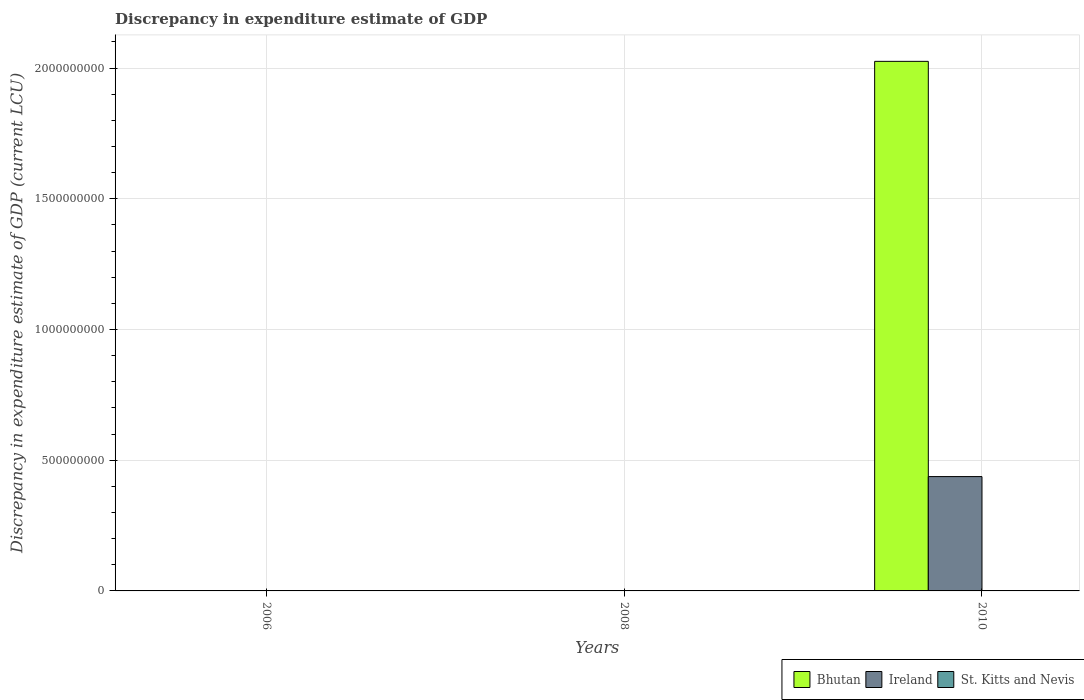How many different coloured bars are there?
Your answer should be compact. 3. Are the number of bars per tick equal to the number of legend labels?
Make the answer very short. No. Are the number of bars on each tick of the X-axis equal?
Make the answer very short. No. How many bars are there on the 3rd tick from the left?
Offer a very short reply. 3. How many bars are there on the 3rd tick from the right?
Give a very brief answer. 1. What is the label of the 3rd group of bars from the left?
Provide a short and direct response. 2010. In how many cases, is the number of bars for a given year not equal to the number of legend labels?
Your answer should be compact. 2. What is the discrepancy in expenditure estimate of GDP in St. Kitts and Nevis in 2008?
Ensure brevity in your answer.  2e-7. Across all years, what is the maximum discrepancy in expenditure estimate of GDP in St. Kitts and Nevis?
Provide a short and direct response. 3.2e-7. Across all years, what is the minimum discrepancy in expenditure estimate of GDP in Ireland?
Keep it short and to the point. 0. In which year was the discrepancy in expenditure estimate of GDP in St. Kitts and Nevis maximum?
Your answer should be very brief. 2010. What is the total discrepancy in expenditure estimate of GDP in Ireland in the graph?
Make the answer very short. 4.37e+08. What is the difference between the discrepancy in expenditure estimate of GDP in Bhutan in 2006 and that in 2008?
Your response must be concise. 4.000000000000001e-6. What is the difference between the discrepancy in expenditure estimate of GDP in St. Kitts and Nevis in 2008 and the discrepancy in expenditure estimate of GDP in Bhutan in 2010?
Give a very brief answer. -2.03e+09. What is the average discrepancy in expenditure estimate of GDP in Ireland per year?
Your response must be concise. 1.46e+08. In the year 2010, what is the difference between the discrepancy in expenditure estimate of GDP in Bhutan and discrepancy in expenditure estimate of GDP in St. Kitts and Nevis?
Ensure brevity in your answer.  2.03e+09. In how many years, is the discrepancy in expenditure estimate of GDP in Ireland greater than 1700000000 LCU?
Your response must be concise. 0. What is the ratio of the discrepancy in expenditure estimate of GDP in St. Kitts and Nevis in 2008 to that in 2010?
Ensure brevity in your answer.  0.62. What is the difference between the highest and the second highest discrepancy in expenditure estimate of GDP in Bhutan?
Make the answer very short. 2.03e+09. What is the difference between the highest and the lowest discrepancy in expenditure estimate of GDP in St. Kitts and Nevis?
Give a very brief answer. 3.2e-7. How many bars are there?
Offer a terse response. 6. Are all the bars in the graph horizontal?
Your answer should be compact. No. How many years are there in the graph?
Ensure brevity in your answer.  3. Are the values on the major ticks of Y-axis written in scientific E-notation?
Give a very brief answer. No. Does the graph contain any zero values?
Offer a very short reply. Yes. Where does the legend appear in the graph?
Give a very brief answer. Bottom right. How are the legend labels stacked?
Keep it short and to the point. Horizontal. What is the title of the graph?
Your response must be concise. Discrepancy in expenditure estimate of GDP. Does "Macao" appear as one of the legend labels in the graph?
Offer a terse response. No. What is the label or title of the X-axis?
Ensure brevity in your answer.  Years. What is the label or title of the Y-axis?
Ensure brevity in your answer.  Discrepancy in expenditure estimate of GDP (current LCU). What is the Discrepancy in expenditure estimate of GDP (current LCU) of Bhutan in 2006?
Your answer should be very brief. 6e-6. What is the Discrepancy in expenditure estimate of GDP (current LCU) of Ireland in 2006?
Ensure brevity in your answer.  0. What is the Discrepancy in expenditure estimate of GDP (current LCU) of St. Kitts and Nevis in 2006?
Give a very brief answer. 0. What is the Discrepancy in expenditure estimate of GDP (current LCU) in Bhutan in 2008?
Give a very brief answer. 2e-6. What is the Discrepancy in expenditure estimate of GDP (current LCU) in St. Kitts and Nevis in 2008?
Make the answer very short. 2e-7. What is the Discrepancy in expenditure estimate of GDP (current LCU) of Bhutan in 2010?
Your response must be concise. 2.03e+09. What is the Discrepancy in expenditure estimate of GDP (current LCU) in Ireland in 2010?
Provide a succinct answer. 4.37e+08. What is the Discrepancy in expenditure estimate of GDP (current LCU) of St. Kitts and Nevis in 2010?
Your answer should be compact. 3.2e-7. Across all years, what is the maximum Discrepancy in expenditure estimate of GDP (current LCU) of Bhutan?
Your answer should be compact. 2.03e+09. Across all years, what is the maximum Discrepancy in expenditure estimate of GDP (current LCU) of Ireland?
Your answer should be compact. 4.37e+08. Across all years, what is the maximum Discrepancy in expenditure estimate of GDP (current LCU) in St. Kitts and Nevis?
Your answer should be very brief. 3.2e-7. Across all years, what is the minimum Discrepancy in expenditure estimate of GDP (current LCU) in Bhutan?
Make the answer very short. 2e-6. Across all years, what is the minimum Discrepancy in expenditure estimate of GDP (current LCU) in Ireland?
Ensure brevity in your answer.  0. Across all years, what is the minimum Discrepancy in expenditure estimate of GDP (current LCU) in St. Kitts and Nevis?
Give a very brief answer. 0. What is the total Discrepancy in expenditure estimate of GDP (current LCU) in Bhutan in the graph?
Offer a very short reply. 2.03e+09. What is the total Discrepancy in expenditure estimate of GDP (current LCU) in Ireland in the graph?
Give a very brief answer. 4.37e+08. What is the total Discrepancy in expenditure estimate of GDP (current LCU) of St. Kitts and Nevis in the graph?
Offer a very short reply. 0. What is the difference between the Discrepancy in expenditure estimate of GDP (current LCU) in Bhutan in 2006 and that in 2010?
Give a very brief answer. -2.03e+09. What is the difference between the Discrepancy in expenditure estimate of GDP (current LCU) of Bhutan in 2008 and that in 2010?
Make the answer very short. -2.03e+09. What is the difference between the Discrepancy in expenditure estimate of GDP (current LCU) in Bhutan in 2006 and the Discrepancy in expenditure estimate of GDP (current LCU) in Ireland in 2010?
Ensure brevity in your answer.  -4.37e+08. What is the difference between the Discrepancy in expenditure estimate of GDP (current LCU) of Bhutan in 2006 and the Discrepancy in expenditure estimate of GDP (current LCU) of St. Kitts and Nevis in 2010?
Offer a very short reply. 0. What is the difference between the Discrepancy in expenditure estimate of GDP (current LCU) of Bhutan in 2008 and the Discrepancy in expenditure estimate of GDP (current LCU) of Ireland in 2010?
Your response must be concise. -4.37e+08. What is the difference between the Discrepancy in expenditure estimate of GDP (current LCU) of Bhutan in 2008 and the Discrepancy in expenditure estimate of GDP (current LCU) of St. Kitts and Nevis in 2010?
Provide a succinct answer. 0. What is the average Discrepancy in expenditure estimate of GDP (current LCU) of Bhutan per year?
Keep it short and to the point. 6.75e+08. What is the average Discrepancy in expenditure estimate of GDP (current LCU) in Ireland per year?
Your response must be concise. 1.46e+08. What is the average Discrepancy in expenditure estimate of GDP (current LCU) of St. Kitts and Nevis per year?
Your answer should be compact. 0. In the year 2008, what is the difference between the Discrepancy in expenditure estimate of GDP (current LCU) of Bhutan and Discrepancy in expenditure estimate of GDP (current LCU) of St. Kitts and Nevis?
Offer a terse response. 0. In the year 2010, what is the difference between the Discrepancy in expenditure estimate of GDP (current LCU) in Bhutan and Discrepancy in expenditure estimate of GDP (current LCU) in Ireland?
Offer a very short reply. 1.59e+09. In the year 2010, what is the difference between the Discrepancy in expenditure estimate of GDP (current LCU) in Bhutan and Discrepancy in expenditure estimate of GDP (current LCU) in St. Kitts and Nevis?
Provide a short and direct response. 2.03e+09. In the year 2010, what is the difference between the Discrepancy in expenditure estimate of GDP (current LCU) in Ireland and Discrepancy in expenditure estimate of GDP (current LCU) in St. Kitts and Nevis?
Offer a very short reply. 4.37e+08. What is the ratio of the Discrepancy in expenditure estimate of GDP (current LCU) of Bhutan in 2006 to that in 2008?
Provide a succinct answer. 3. What is the ratio of the Discrepancy in expenditure estimate of GDP (current LCU) in Bhutan in 2006 to that in 2010?
Ensure brevity in your answer.  0. What is the ratio of the Discrepancy in expenditure estimate of GDP (current LCU) in Bhutan in 2008 to that in 2010?
Make the answer very short. 0. What is the difference between the highest and the second highest Discrepancy in expenditure estimate of GDP (current LCU) in Bhutan?
Your answer should be compact. 2.03e+09. What is the difference between the highest and the lowest Discrepancy in expenditure estimate of GDP (current LCU) in Bhutan?
Offer a very short reply. 2.03e+09. What is the difference between the highest and the lowest Discrepancy in expenditure estimate of GDP (current LCU) of Ireland?
Provide a short and direct response. 4.37e+08. 